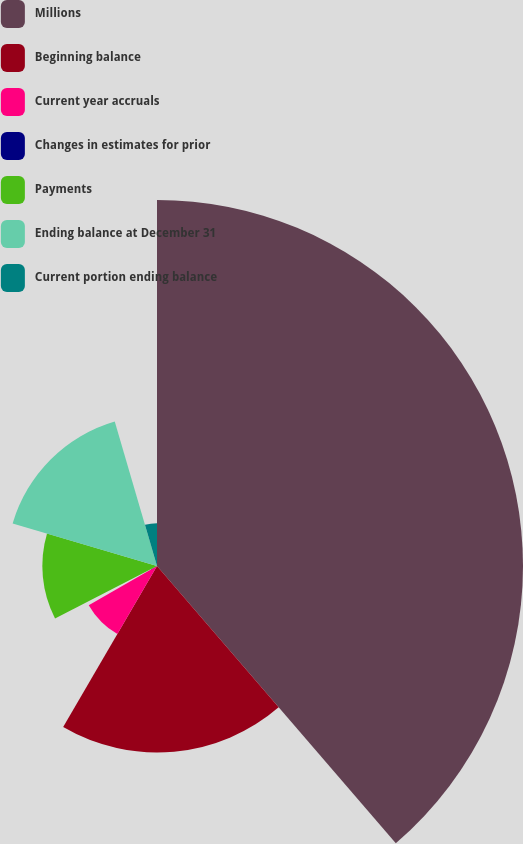<chart> <loc_0><loc_0><loc_500><loc_500><pie_chart><fcel>Millions<fcel>Beginning balance<fcel>Current year accruals<fcel>Changes in estimates for prior<fcel>Payments<fcel>Ending balance at December 31<fcel>Current portion ending balance<nl><fcel>38.69%<fcel>19.71%<fcel>8.32%<fcel>0.73%<fcel>12.12%<fcel>15.91%<fcel>4.53%<nl></chart> 